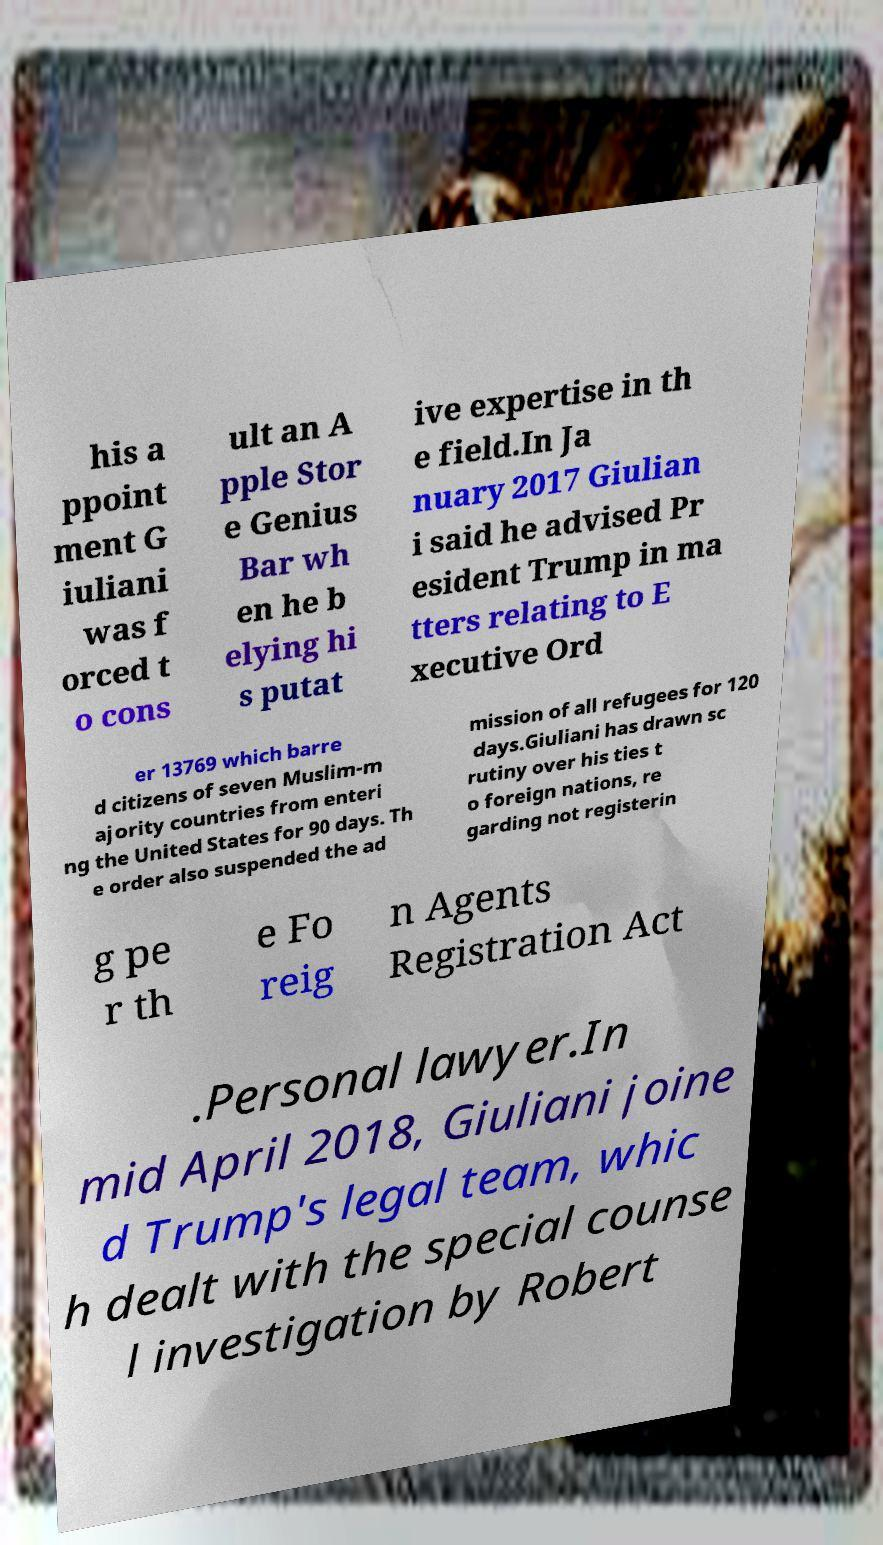There's text embedded in this image that I need extracted. Can you transcribe it verbatim? his a ppoint ment G iuliani was f orced t o cons ult an A pple Stor e Genius Bar wh en he b elying hi s putat ive expertise in th e field.In Ja nuary 2017 Giulian i said he advised Pr esident Trump in ma tters relating to E xecutive Ord er 13769 which barre d citizens of seven Muslim-m ajority countries from enteri ng the United States for 90 days. Th e order also suspended the ad mission of all refugees for 120 days.Giuliani has drawn sc rutiny over his ties t o foreign nations, re garding not registerin g pe r th e Fo reig n Agents Registration Act .Personal lawyer.In mid April 2018, Giuliani joine d Trump's legal team, whic h dealt with the special counse l investigation by Robert 